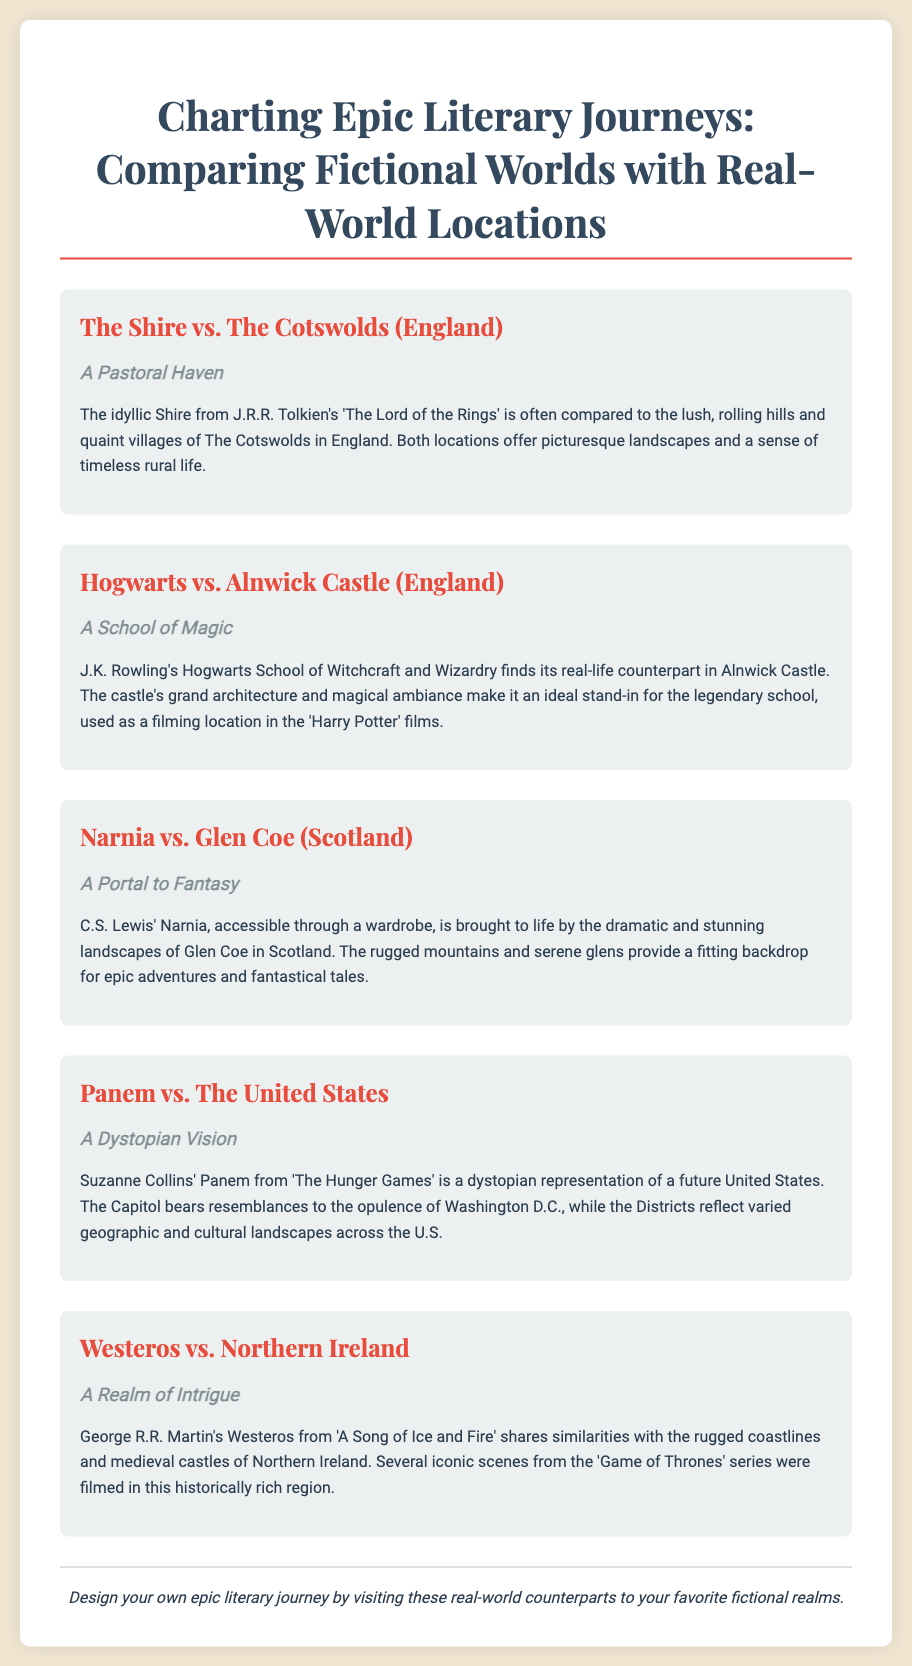What are the two locations compared for The Shire? The document mentions The Shire being compared to The Cotswolds (England).
Answer: The Cotswolds (England) Which fictional school is associated with Alnwick Castle? Alnwick Castle is the real-life counterpart of Hogwarts School of Witchcraft and Wizardry.
Answer: Hogwarts What is the fictional land accessible through a wardrobe? C.S. Lewis' fictional land that is accessed through a wardrobe is Narnia.
Answer: Narnia What type of representation is Panem said to be? Panem is described as a dystopian representation of a future United States.
Answer: Dystopian representation Which region is Westeros compared to in the poster? Westeros is compared to Northern Ireland in the document.
Answer: Northern Ireland How many sections compare fictional worlds with real-world locations? The document presents five sections that compare different fictional worlds with real-world locations.
Answer: Five What is the design intent mentioned in the footer? The footer suggests designing your own epic literary journey by visiting real-world counterparts.
Answer: Epic literary journey What film series features Alnwick Castle as a filming location? Alnwick Castle was used as a filming location in the 'Harry Potter' films.
Answer: Harry Potter What kind of landscapes does Glen Coe provide for Narnia? Glen Coe provides dramatic and stunning landscapes for Narnia.
Answer: Dramatic and stunning landscapes 